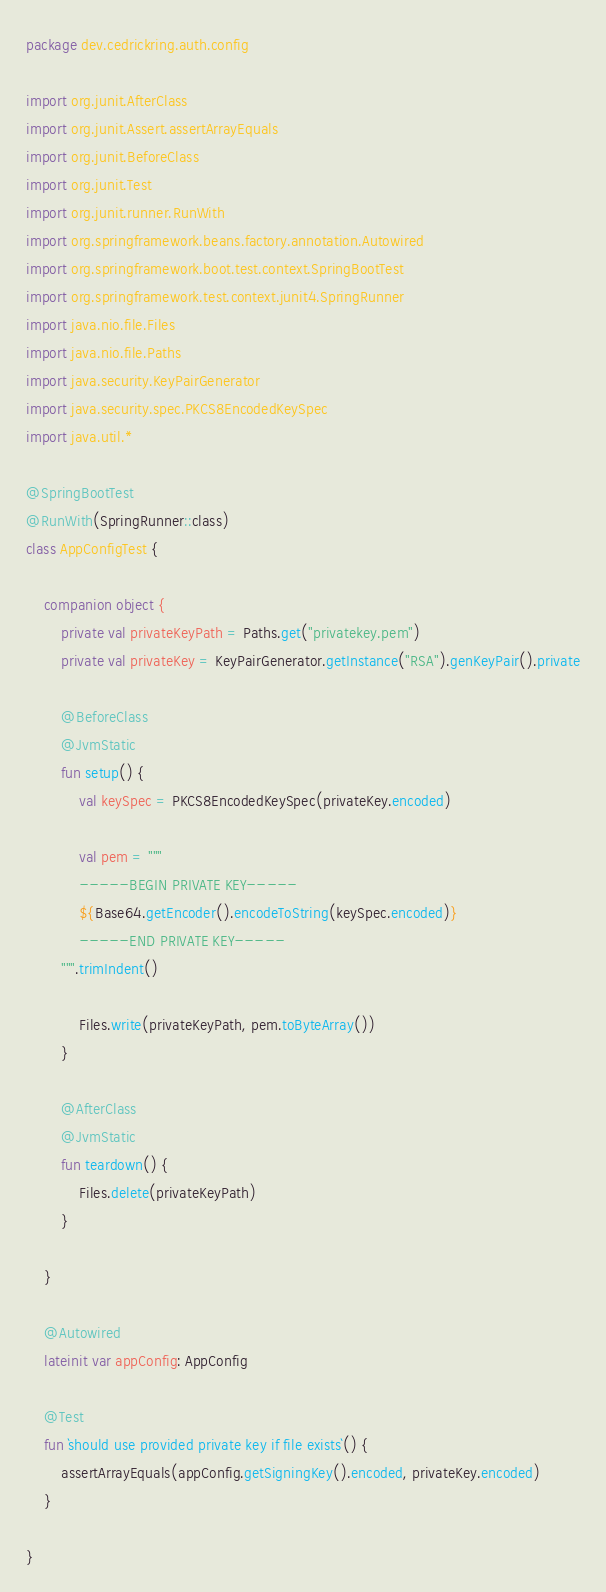<code> <loc_0><loc_0><loc_500><loc_500><_Kotlin_>package dev.cedrickring.auth.config

import org.junit.AfterClass
import org.junit.Assert.assertArrayEquals
import org.junit.BeforeClass
import org.junit.Test
import org.junit.runner.RunWith
import org.springframework.beans.factory.annotation.Autowired
import org.springframework.boot.test.context.SpringBootTest
import org.springframework.test.context.junit4.SpringRunner
import java.nio.file.Files
import java.nio.file.Paths
import java.security.KeyPairGenerator
import java.security.spec.PKCS8EncodedKeySpec
import java.util.*

@SpringBootTest
@RunWith(SpringRunner::class)
class AppConfigTest {

    companion object {
        private val privateKeyPath = Paths.get("privatekey.pem")
        private val privateKey = KeyPairGenerator.getInstance("RSA").genKeyPair().private

        @BeforeClass
        @JvmStatic
        fun setup() {
            val keySpec = PKCS8EncodedKeySpec(privateKey.encoded)

            val pem = """
            -----BEGIN PRIVATE KEY-----
            ${Base64.getEncoder().encodeToString(keySpec.encoded)}
            -----END PRIVATE KEY-----
        """.trimIndent()

            Files.write(privateKeyPath, pem.toByteArray())
        }

        @AfterClass
        @JvmStatic
        fun teardown() {
            Files.delete(privateKeyPath)
        }

    }

    @Autowired
    lateinit var appConfig: AppConfig

    @Test
    fun `should use provided private key if file exists`() {
        assertArrayEquals(appConfig.getSigningKey().encoded, privateKey.encoded)
    }

}
</code> 